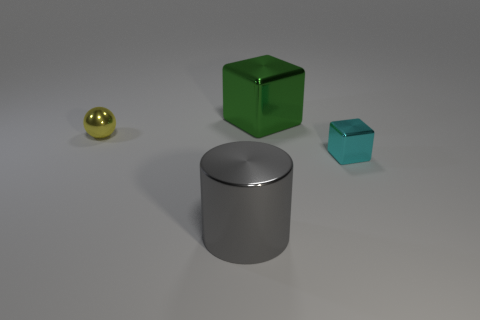Add 3 big gray cylinders. How many objects exist? 7 Subtract all cylinders. How many objects are left? 3 Subtract 0 gray spheres. How many objects are left? 4 Subtract all small green cylinders. Subtract all gray cylinders. How many objects are left? 3 Add 2 small cyan metal blocks. How many small cyan metal blocks are left? 3 Add 4 big red spheres. How many big red spheres exist? 4 